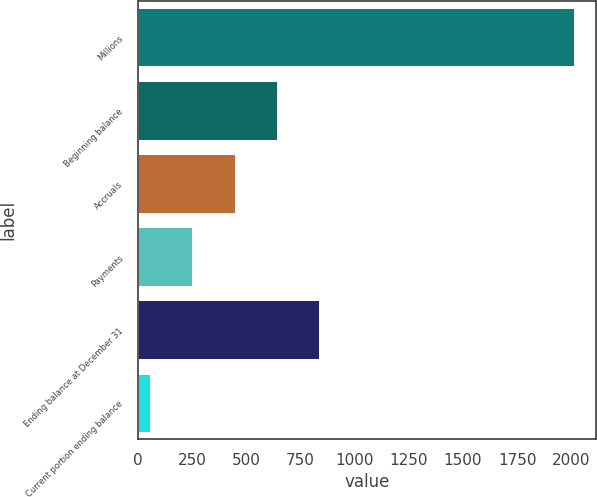Convert chart to OTSL. <chart><loc_0><loc_0><loc_500><loc_500><bar_chart><fcel>Millions<fcel>Beginning balance<fcel>Accruals<fcel>Payments<fcel>Ending balance at December 31<fcel>Current portion ending balance<nl><fcel>2013<fcel>641<fcel>445<fcel>249<fcel>837<fcel>53<nl></chart> 